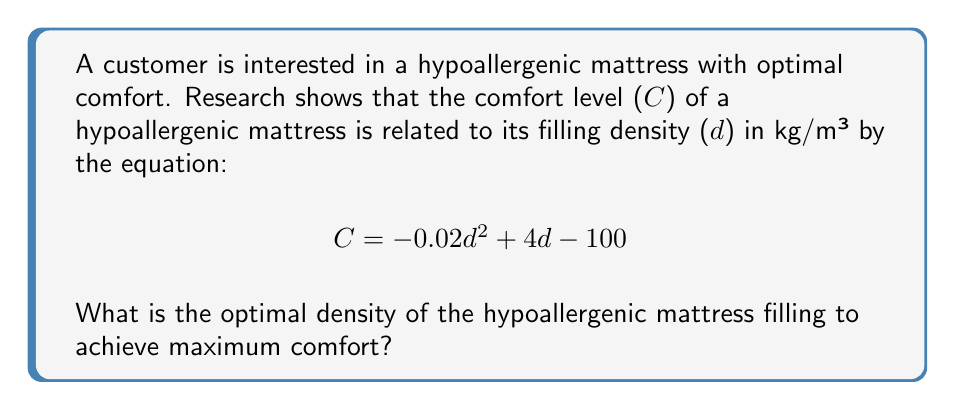Give your solution to this math problem. To find the optimal density for maximum comfort, we need to find the maximum point of the given quadratic function. This can be done by following these steps:

1. The function for comfort level is:
   $$C = -0.02d^2 + 4d - 100$$

2. To find the maximum point, we need to find where the derivative of C with respect to d equals zero:
   $$\frac{dC}{dd} = -0.04d + 4 = 0$$

3. Solve for d:
   $$-0.04d + 4 = 0$$
   $$-0.04d = -4$$
   $$d = \frac{-4}{-0.04} = 100$$

4. To confirm this is a maximum (not a minimum), check the second derivative:
   $$\frac{d^2C}{dd^2} = -0.04$$
   Since this is negative, we confirm that d = 100 gives a maximum.

5. Therefore, the optimal density is 100 kg/m³.
Answer: 100 kg/m³ 